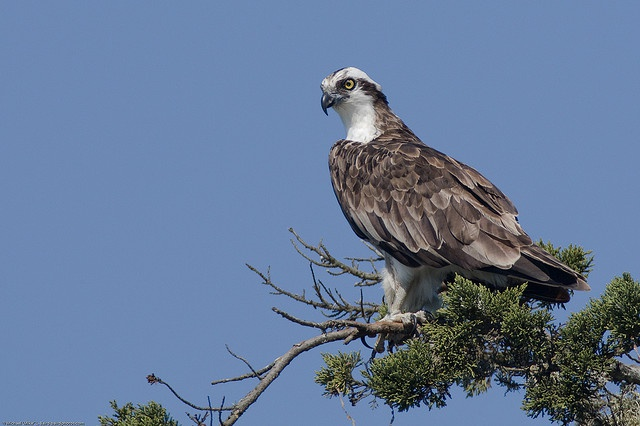Describe the objects in this image and their specific colors. I can see a bird in gray, black, and darkgray tones in this image. 